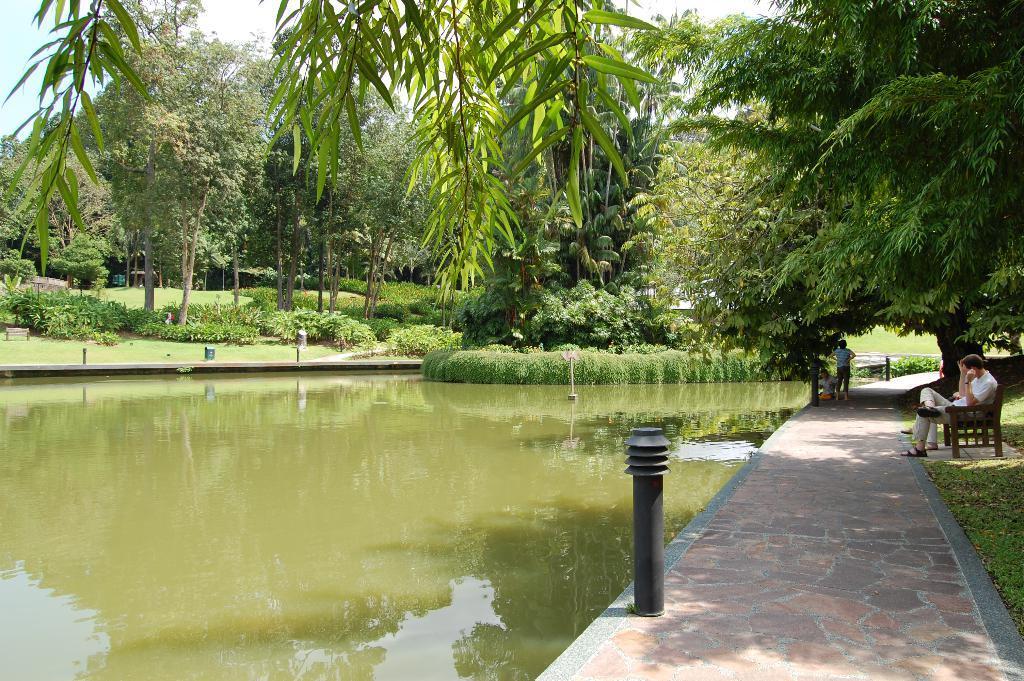How would you summarize this image in a sentence or two? At the center of the image there is a pond. On the right side of the image there is a person sitting on the bench. In front of the person there is a pavement, on the pavement there are another two persons standing. In the background there are trees, plants and grass. 